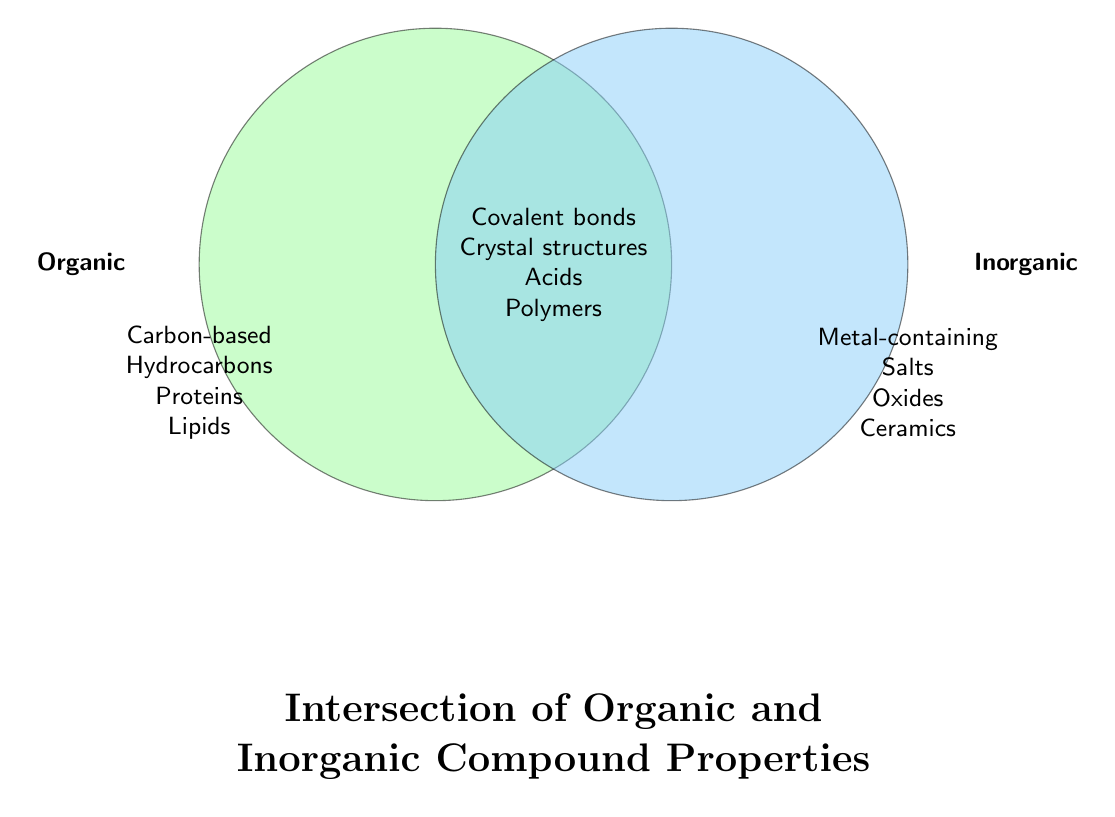What is the title of the Venn Diagram? The title is located at the bottom of the diagram, written in large, bold, and centered text. It reads "Intersection of Organic and Inorganic Compound Properties."
Answer: Intersection of Organic and Inorganic Compound Properties What colors represent Organic and Inorganic properties? The Organic properties are represented by a light green color, and the Inorganic properties are represented by a light blue color. These colors help distinguish the two types of compounds in the Venn Diagram.
Answer: Organic: Light green, Inorganic: Light blue Which compounds have both organic and inorganic properties? The compounds that fall into both categories are located in the overlapping section of the Venn Diagram, between the light green and blue areas. These are Covalent bonds, Crystal structures, Acids, and Polymers.
Answer: Covalent bonds, Crystal structures, Acids, Polymers What property types do vitamins belong to? Vitamins fall within the Organic category, which is shown in the light green circle on the left side of the Venn Diagram.
Answer: Organic How many properties are unique to Inorganic compounds? In the Inorganic category on the right side of the diagram, there are seven properties listed: Metal-containing, Salts, Oxides, Ceramics, Silicon compounds, Minerals, Alloys. Count these properties to get the total.
Answer: 7 Which category, Organic or Inorganic, has more exclusive properties listed? Count the properties listed under each category. The Organic side has six properties: Carbon-based, Hydrocarbons, Proteins, Lipids, DNA, Carbohydrates, Vitamins. The Inorganic side has seven properties. Therefore, Inorganic has more exclusive properties.
Answer: Inorganic Are Catalysts considered an Organic or an Inorganic property? According to the Venn Diagram data, Catalysts are in the "Both" category which means they have both organic and inorganic properties.
Answer: Both 